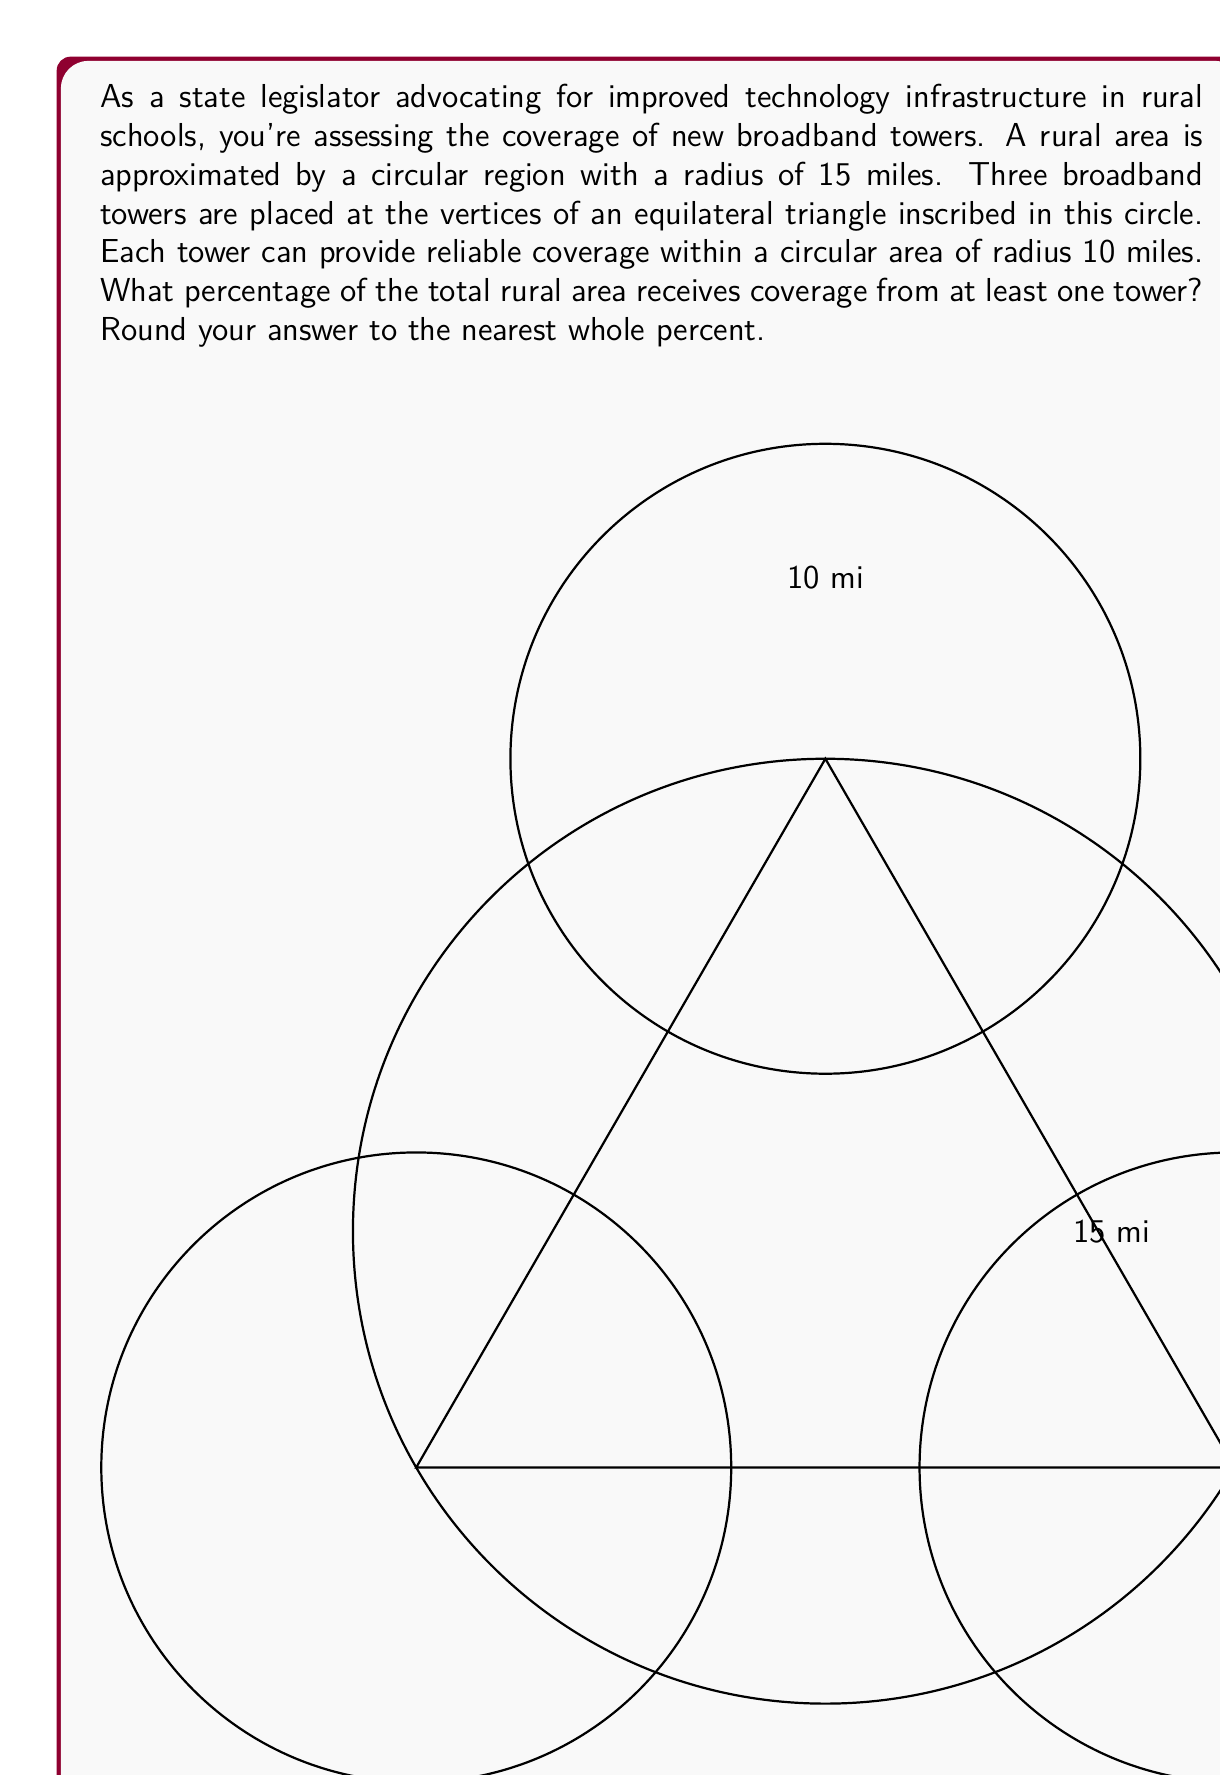Give your solution to this math problem. Let's approach this step-by-step:

1) First, we need to calculate the area of the entire rural region:
   $$A_{total} = \pi r^2 = \pi (15)^2 = 225\pi \text{ sq miles}$$

2) Next, we need to find the area covered by the three towers. This is a complex shape formed by the intersection of three circles. To simplify, we'll calculate the area of one circle and multiply by 3, then subtract the areas of overlap.

3) Area of one tower's coverage:
   $$A_{tower} = \pi r^2 = \pi (10)^2 = 100\pi \text{ sq miles}$$

4) To find the overlap, we need to calculate the distance between tower centers. In an equilateral triangle inscribed in a circle of radius R, the side length is $\sqrt{3}R$. Here, $R=15$, so the distance between towers is $15\sqrt{3} \approx 25.98$ miles.

5) The overlap between two circles can be calculated using the formula:
   $$A_{overlap} = 2r^2 \arccos(\frac{d}{2r}) - d\sqrt{r^2 - (\frac{d}{2})^2}$$
   where $r$ is the radius of each circle (10) and $d$ is the distance between centers (25.98).

6) Plugging in the values:
   $$A_{overlap} \approx 21.46 \text{ sq miles}$$

7) There are three such overlaps, one for each pair of circles.

8) The total covered area is then:
   $$A_{covered} = 3A_{tower} - 3A_{overlap} = 3(100\pi) - 3(21.46) \approx 879.62 \text{ sq miles}$$

9) The percentage covered is:
   $$\text{Percentage} = \frac{A_{covered}}{A_{total}} \times 100\% = \frac{879.62}{225\pi} \times 100\% \approx 124.03\%$$

10) However, this is over 100% because our calculation includes areas outside the 15-mile rural circle. The actual coverage can't exceed 100% of the rural area.

Therefore, we can conclude that the entire rural area (100%) receives coverage from at least one tower.
Answer: 100% 